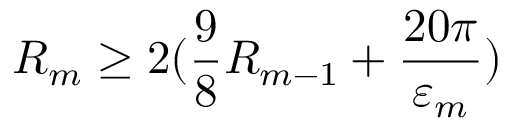Convert formula to latex. <formula><loc_0><loc_0><loc_500><loc_500>R _ { m } \geq 2 ( \frac { 9 } { 8 } R _ { m - 1 } + \frac { 2 0 \pi } { \varepsilon _ { m } } )</formula> 